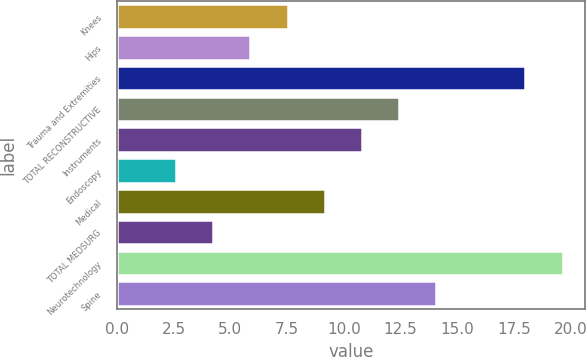<chart> <loc_0><loc_0><loc_500><loc_500><bar_chart><fcel>Knees<fcel>Hips<fcel>Trauma and Extremities<fcel>TOTAL RECONSTRUCTIVE<fcel>Instruments<fcel>Endoscopy<fcel>Medical<fcel>TOTAL MEDSURG<fcel>Neurotechnology<fcel>Spine<nl><fcel>7.52<fcel>5.88<fcel>18<fcel>12.44<fcel>10.8<fcel>2.6<fcel>9.16<fcel>4.24<fcel>19.64<fcel>14.08<nl></chart> 